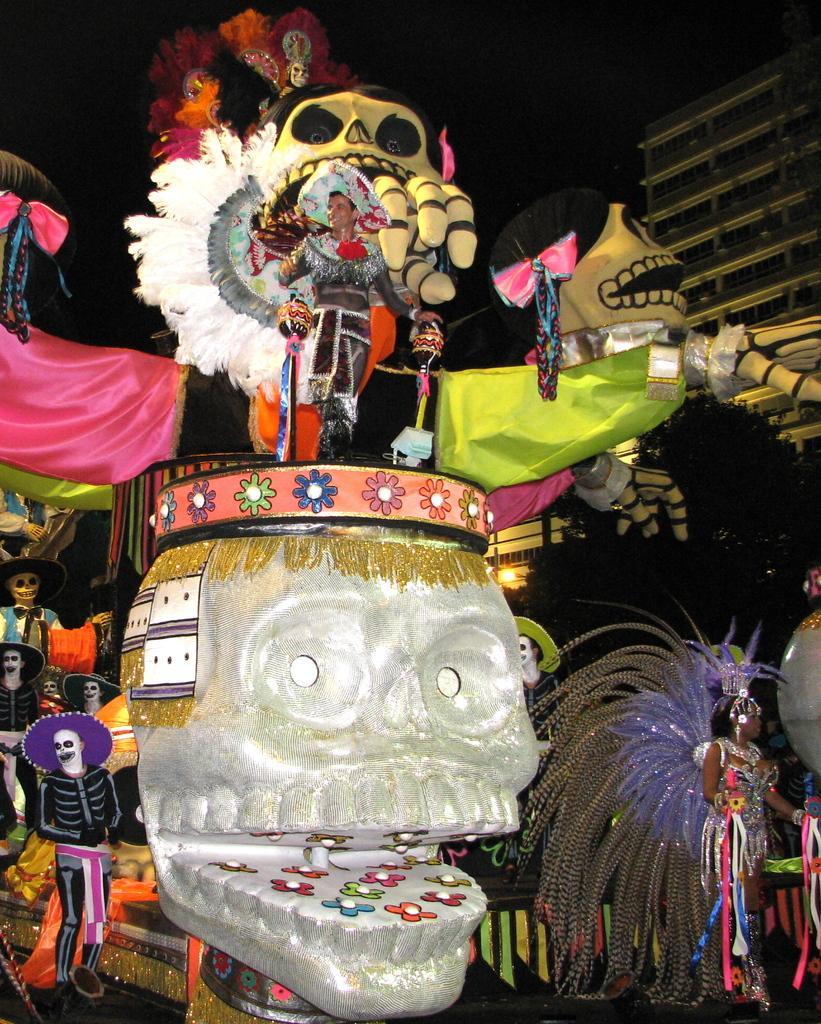Describe this image in one or two sentences. In this picture there is a person standing on the vehicle. On the left side of the image there are group of people with costume are standing. On the right side of the image there is a woman walking on the road. At the back there is a building. At the top there is sky. At the bottom there is a road. 